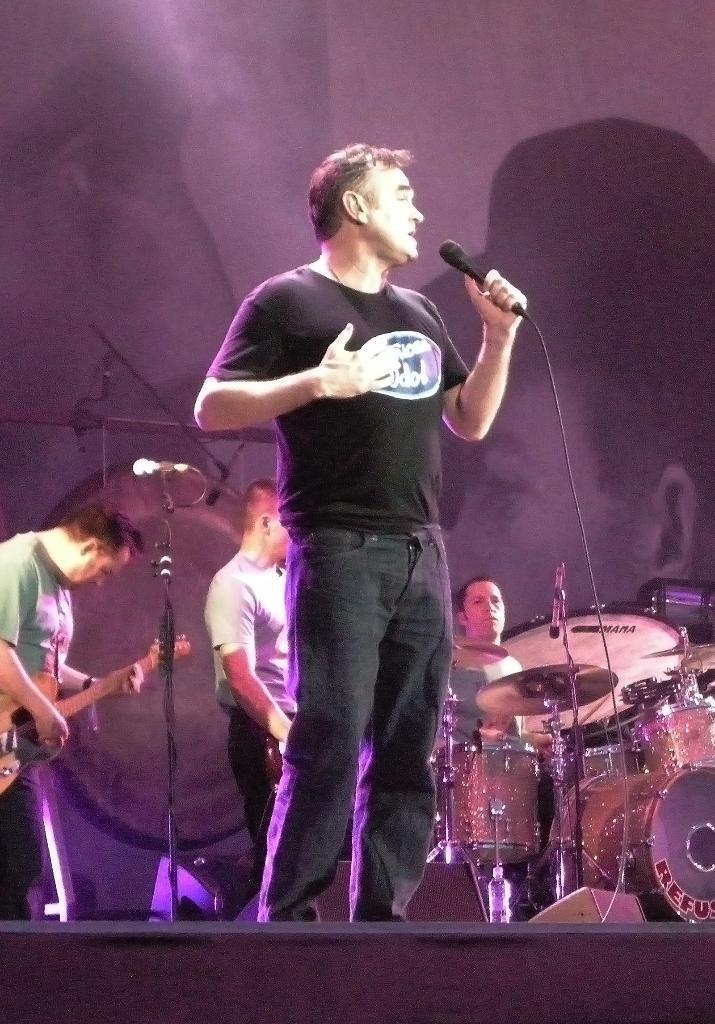Can you describe this image briefly? The person wearing black shirt is standing and singing in front of a mic and there are few people playing musical instruments behind him. 